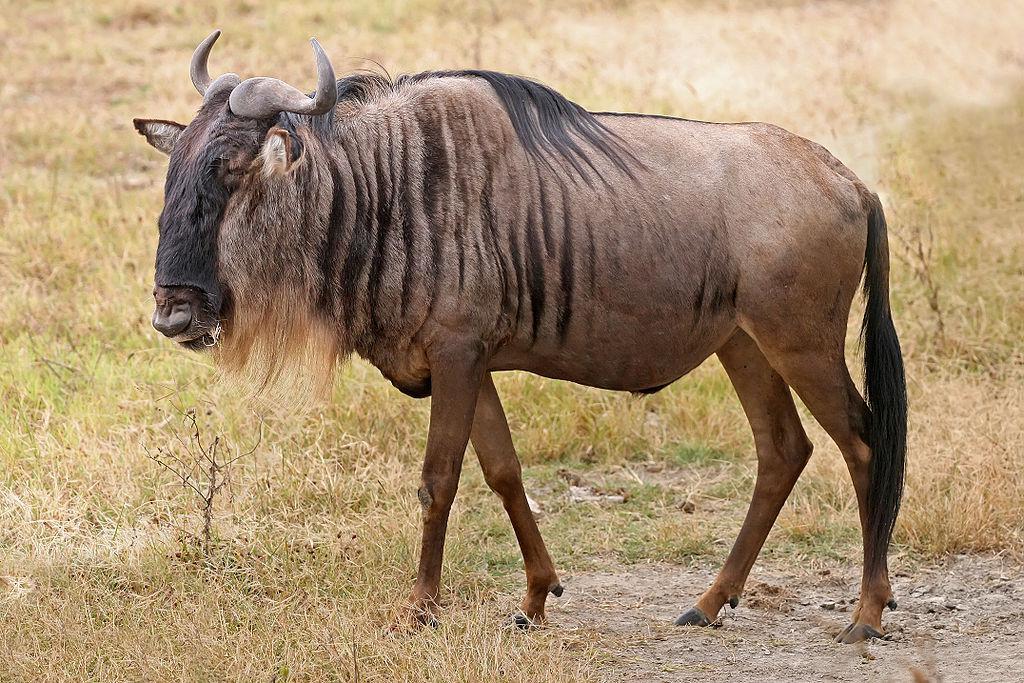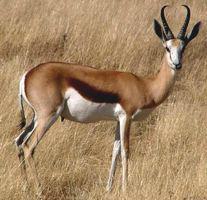The first image is the image on the left, the second image is the image on the right. Considering the images on both sides, is "Each image has one animal that has horns." valid? Answer yes or no. Yes. 